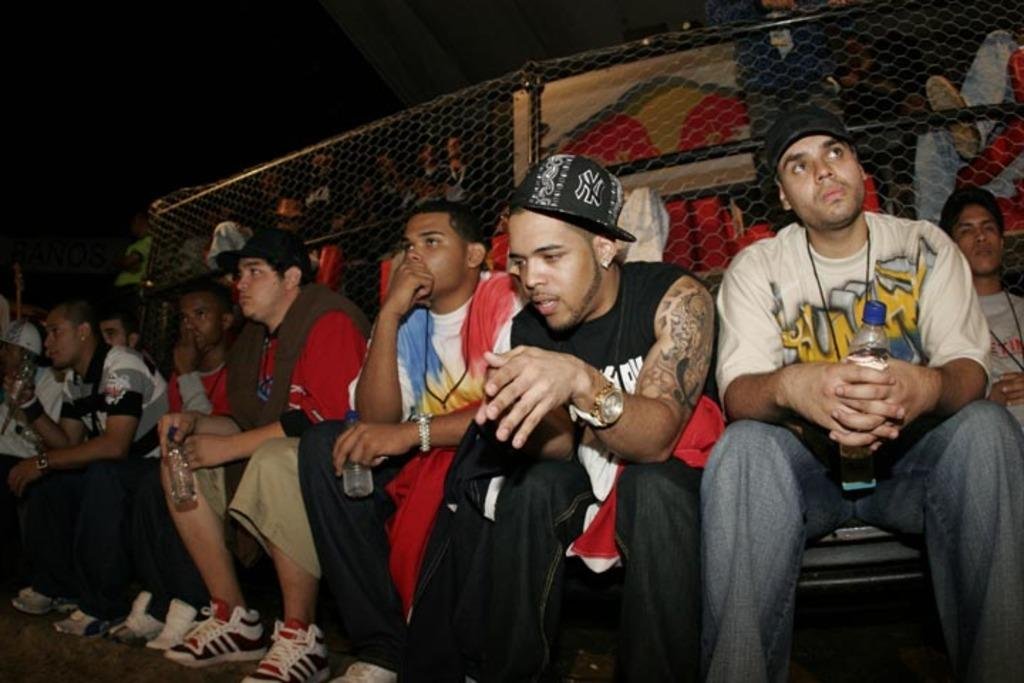What are the people in the front of the image doing? The people in the front of the image are sitting. What type of footwear are the people wearing? The people are wearing shoes. What is the man on the right side of the image holding? The man on the right side of the image is holding a bottle. What can be seen in the background of the image? There is fencing in the background of the image. What type of letter is being passed between the people in the image? There is no letter being passed between the people in the image; they are simply sitting. How many hands are visible in the image? The number of hands visible in the image cannot be determined from the provided facts. 